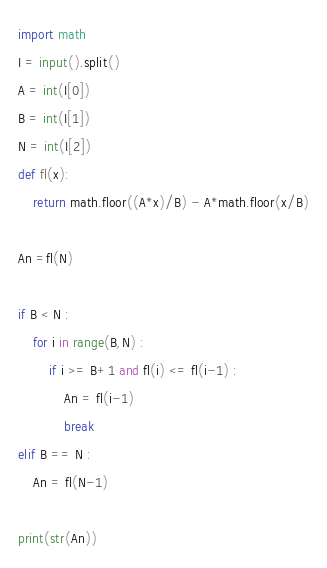<code> <loc_0><loc_0><loc_500><loc_500><_Python_>import math
I = input().split()
A = int(I[0])
B = int(I[1])
N = int(I[2])
def fl(x):
    return math.floor((A*x)/B) - A*math.floor(x/B)

An =fl(N)
   
if B < N :
    for i in range(B,N) :
        if i >= B+1 and fl(i) <= fl(i-1) :
            An = fl(i-1)
            break
elif B == N :
    An = fl(N-1)

print(str(An))</code> 